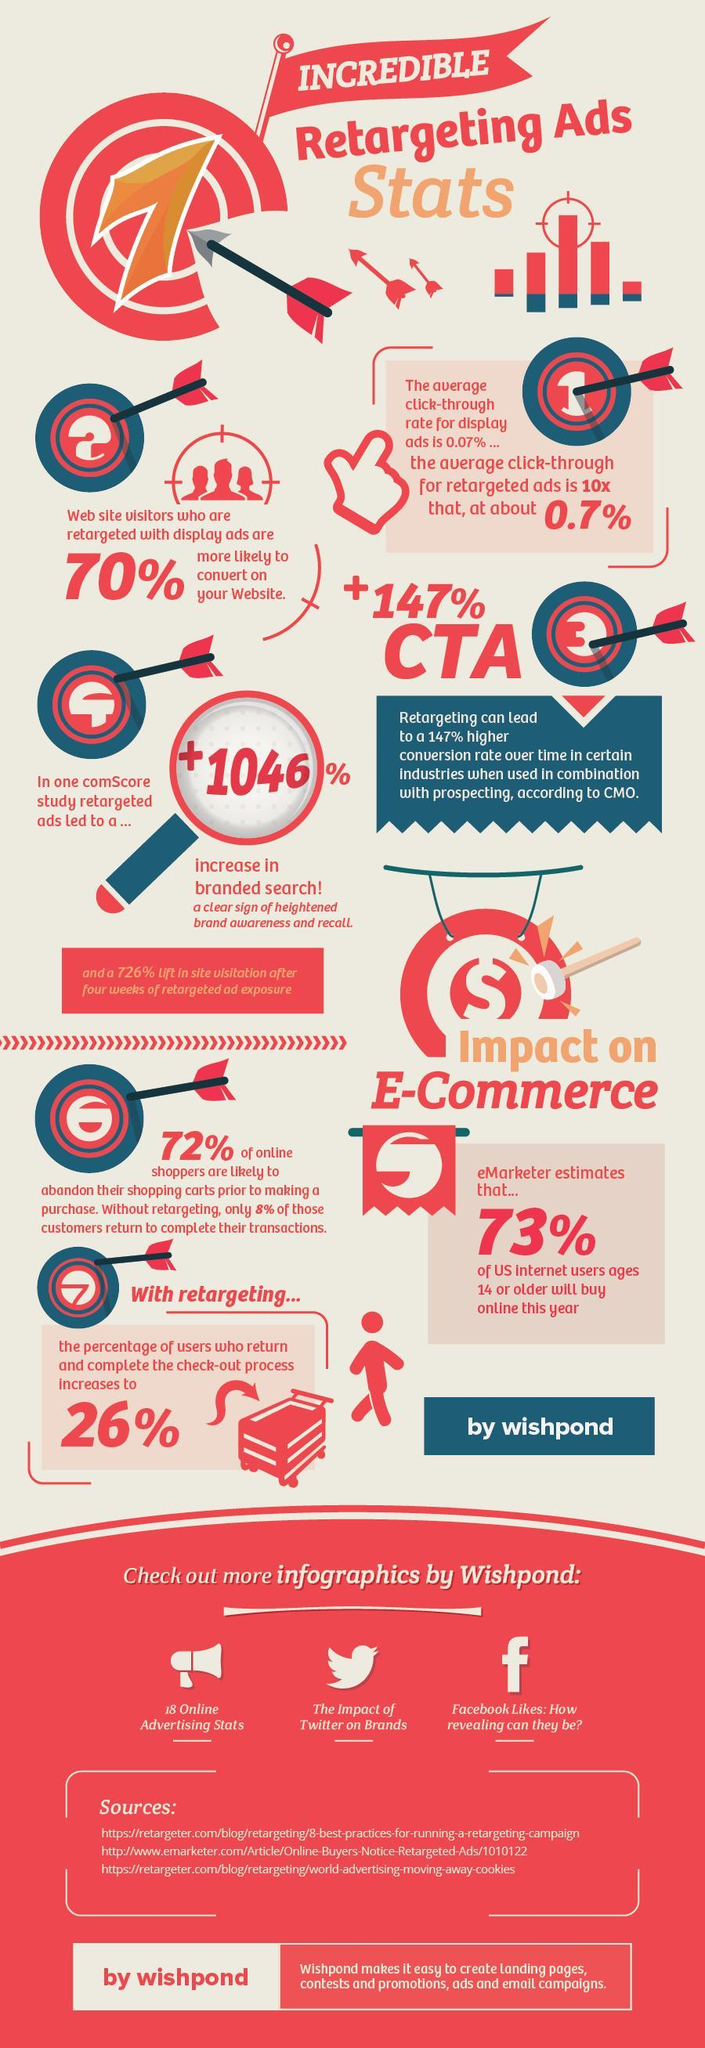How many arrows are in this infographic?
Answer the question with a short phrase. 9 